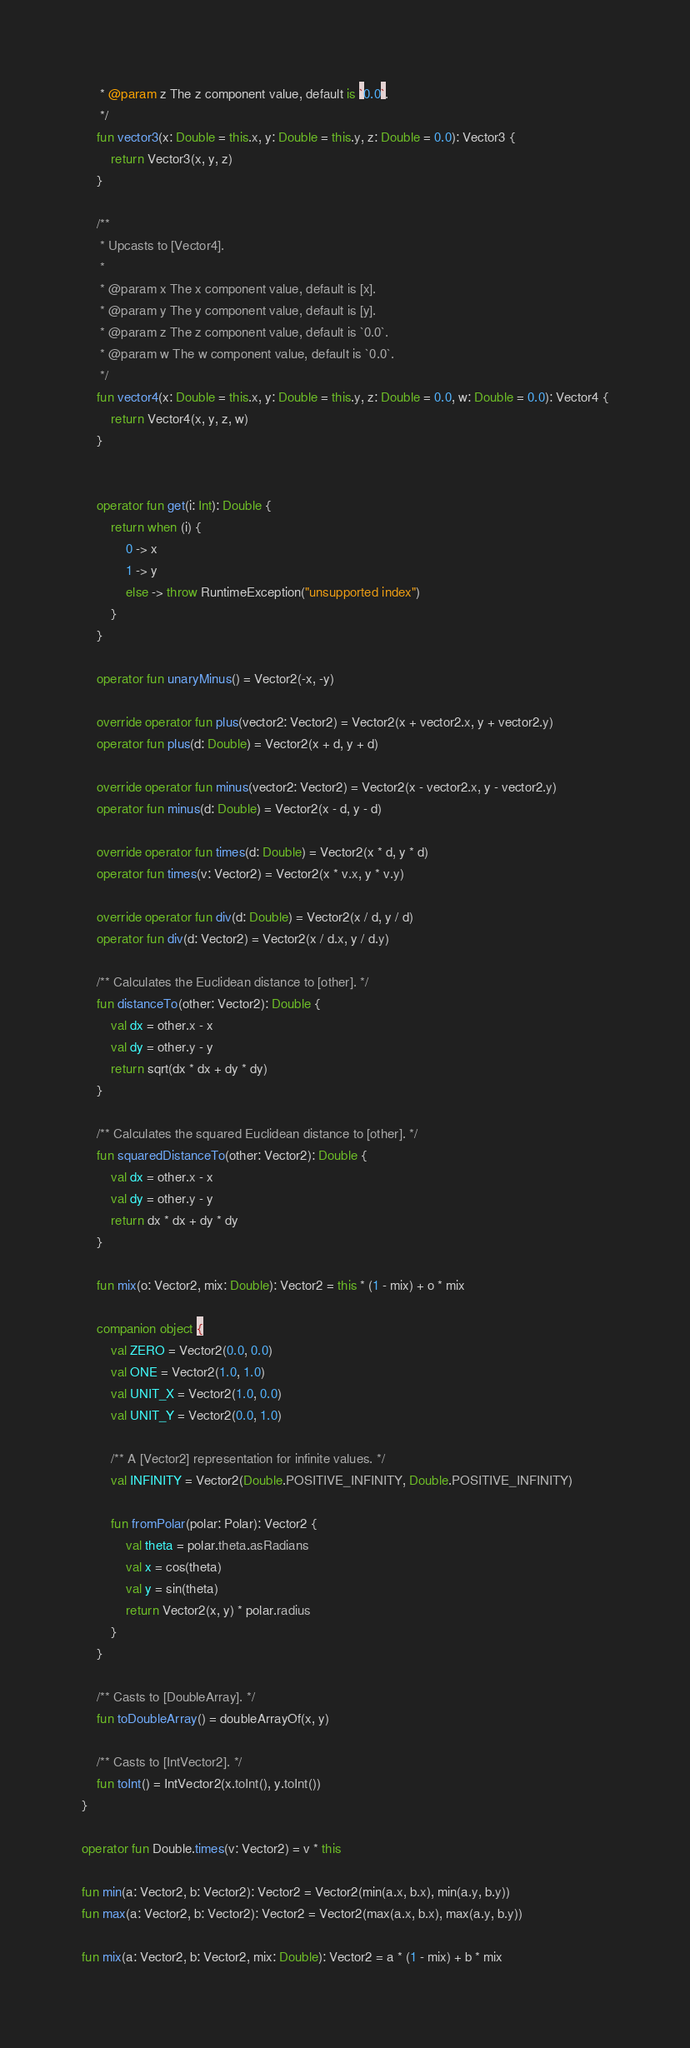Convert code to text. <code><loc_0><loc_0><loc_500><loc_500><_Kotlin_>     * @param z The z component value, default is `0.0`.
     */
    fun vector3(x: Double = this.x, y: Double = this.y, z: Double = 0.0): Vector3 {
        return Vector3(x, y, z)
    }

    /**
     * Upcasts to [Vector4].
     *
     * @param x The x component value, default is [x].
     * @param y The y component value, default is [y].
     * @param z The z component value, default is `0.0`.
     * @param w The w component value, default is `0.0`.
     */
    fun vector4(x: Double = this.x, y: Double = this.y, z: Double = 0.0, w: Double = 0.0): Vector4 {
        return Vector4(x, y, z, w)
    }


    operator fun get(i: Int): Double {
        return when (i) {
            0 -> x
            1 -> y
            else -> throw RuntimeException("unsupported index")
        }
    }

    operator fun unaryMinus() = Vector2(-x, -y)

    override operator fun plus(vector2: Vector2) = Vector2(x + vector2.x, y + vector2.y)
    operator fun plus(d: Double) = Vector2(x + d, y + d)

    override operator fun minus(vector2: Vector2) = Vector2(x - vector2.x, y - vector2.y)
    operator fun minus(d: Double) = Vector2(x - d, y - d)

    override operator fun times(d: Double) = Vector2(x * d, y * d)
    operator fun times(v: Vector2) = Vector2(x * v.x, y * v.y)

    override operator fun div(d: Double) = Vector2(x / d, y / d)
    operator fun div(d: Vector2) = Vector2(x / d.x, y / d.y)

    /** Calculates the Euclidean distance to [other]. */
    fun distanceTo(other: Vector2): Double {
        val dx = other.x - x
        val dy = other.y - y
        return sqrt(dx * dx + dy * dy)
    }

    /** Calculates the squared Euclidean distance to [other]. */
    fun squaredDistanceTo(other: Vector2): Double {
        val dx = other.x - x
        val dy = other.y - y
        return dx * dx + dy * dy
    }

    fun mix(o: Vector2, mix: Double): Vector2 = this * (1 - mix) + o * mix

    companion object {
        val ZERO = Vector2(0.0, 0.0)
        val ONE = Vector2(1.0, 1.0)
        val UNIT_X = Vector2(1.0, 0.0)
        val UNIT_Y = Vector2(0.0, 1.0)

        /** A [Vector2] representation for infinite values. */
        val INFINITY = Vector2(Double.POSITIVE_INFINITY, Double.POSITIVE_INFINITY)

        fun fromPolar(polar: Polar): Vector2 {
            val theta = polar.theta.asRadians
            val x = cos(theta)
            val y = sin(theta)
            return Vector2(x, y) * polar.radius
        }
    }

    /** Casts to [DoubleArray]. */
    fun toDoubleArray() = doubleArrayOf(x, y)

    /** Casts to [IntVector2]. */
    fun toInt() = IntVector2(x.toInt(), y.toInt())
}

operator fun Double.times(v: Vector2) = v * this

fun min(a: Vector2, b: Vector2): Vector2 = Vector2(min(a.x, b.x), min(a.y, b.y))
fun max(a: Vector2, b: Vector2): Vector2 = Vector2(max(a.x, b.x), max(a.y, b.y))

fun mix(a: Vector2, b: Vector2, mix: Double): Vector2 = a * (1 - mix) + b * mix

</code> 